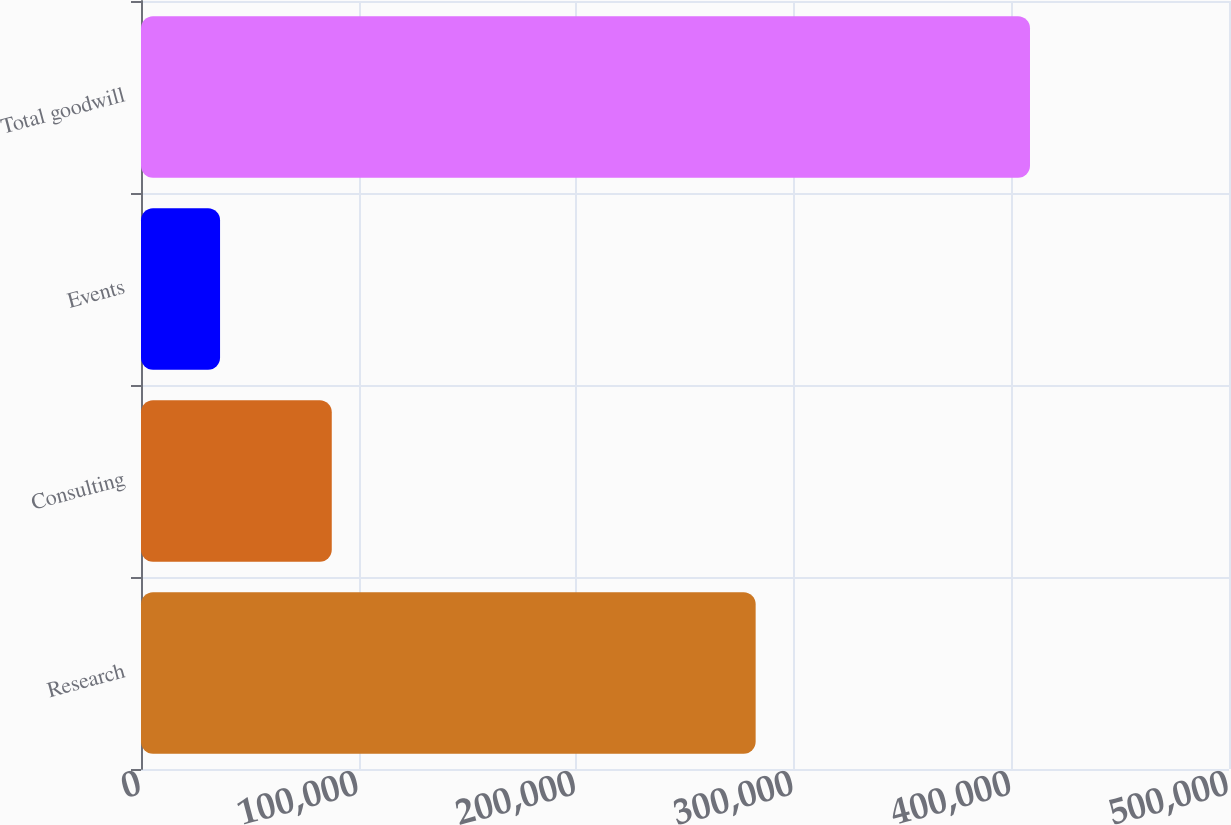<chart> <loc_0><loc_0><loc_500><loc_500><bar_chart><fcel>Research<fcel>Consulting<fcel>Events<fcel>Total goodwill<nl><fcel>282467<fcel>87666<fcel>36330<fcel>408545<nl></chart> 